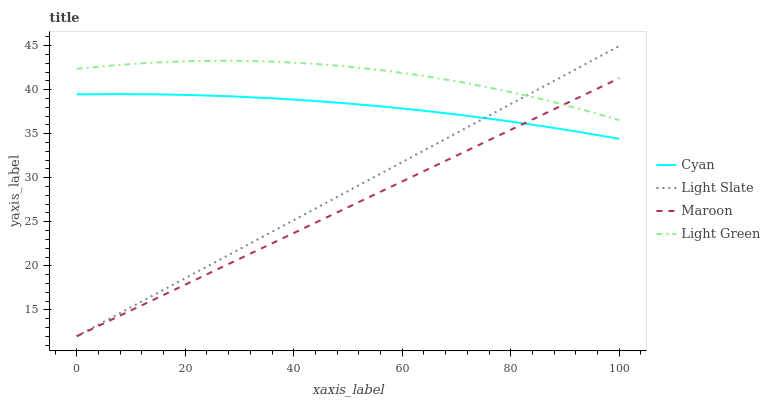Does Maroon have the minimum area under the curve?
Answer yes or no. Yes. Does Light Green have the maximum area under the curve?
Answer yes or no. Yes. Does Cyan have the minimum area under the curve?
Answer yes or no. No. Does Cyan have the maximum area under the curve?
Answer yes or no. No. Is Maroon the smoothest?
Answer yes or no. Yes. Is Light Green the roughest?
Answer yes or no. Yes. Is Cyan the smoothest?
Answer yes or no. No. Is Cyan the roughest?
Answer yes or no. No. Does Cyan have the lowest value?
Answer yes or no. No. Does Light Slate have the highest value?
Answer yes or no. Yes. Does Light Green have the highest value?
Answer yes or no. No. Is Cyan less than Light Green?
Answer yes or no. Yes. Is Light Green greater than Cyan?
Answer yes or no. Yes. Does Light Slate intersect Maroon?
Answer yes or no. Yes. Is Light Slate less than Maroon?
Answer yes or no. No. Is Light Slate greater than Maroon?
Answer yes or no. No. Does Cyan intersect Light Green?
Answer yes or no. No. 